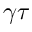Convert formula to latex. <formula><loc_0><loc_0><loc_500><loc_500>\gamma \tau</formula> 